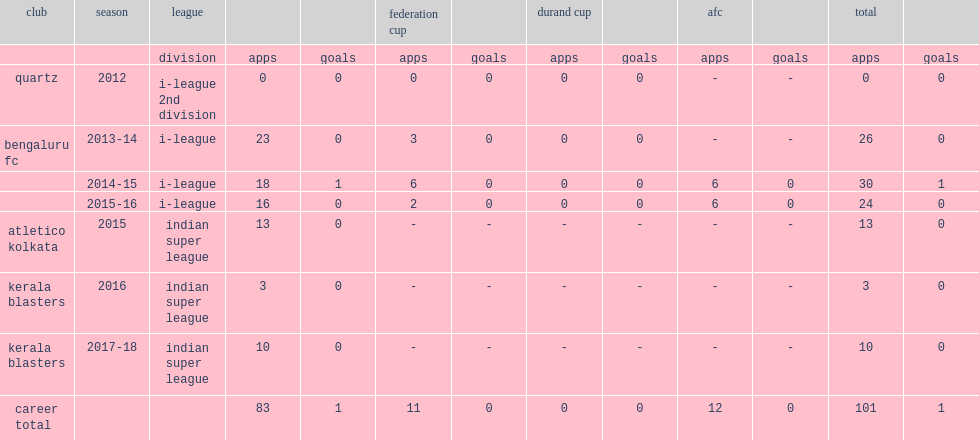Which club did anto play for in 2013-14? Bengaluru fc. 